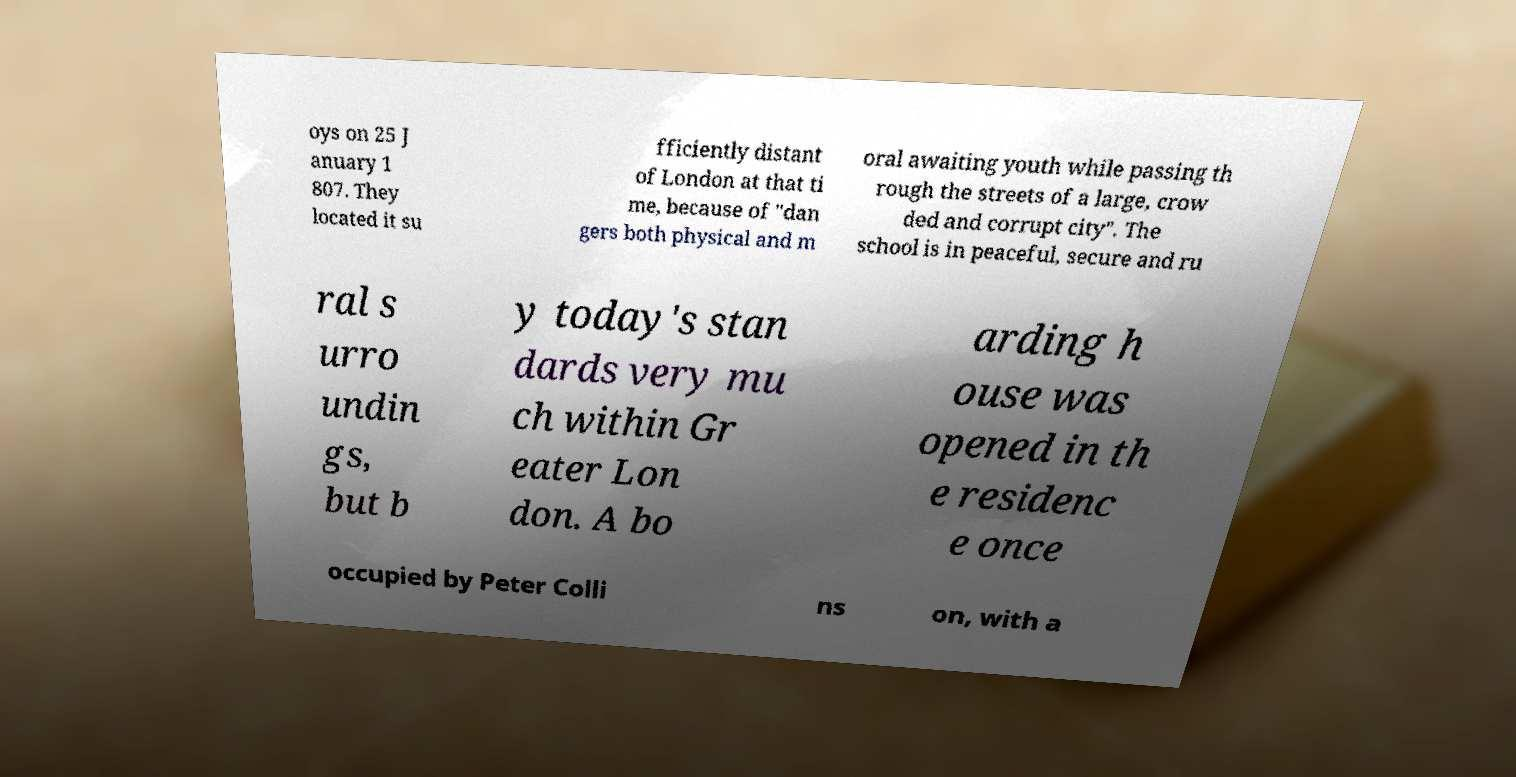There's text embedded in this image that I need extracted. Can you transcribe it verbatim? oys on 25 J anuary 1 807. They located it su fficiently distant of London at that ti me, because of "dan gers both physical and m oral awaiting youth while passing th rough the streets of a large, crow ded and corrupt city". The school is in peaceful, secure and ru ral s urro undin gs, but b y today's stan dards very mu ch within Gr eater Lon don. A bo arding h ouse was opened in th e residenc e once occupied by Peter Colli ns on, with a 